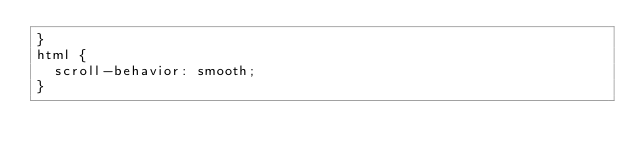<code> <loc_0><loc_0><loc_500><loc_500><_CSS_>}
html {
  scroll-behavior: smooth;
}
</code> 